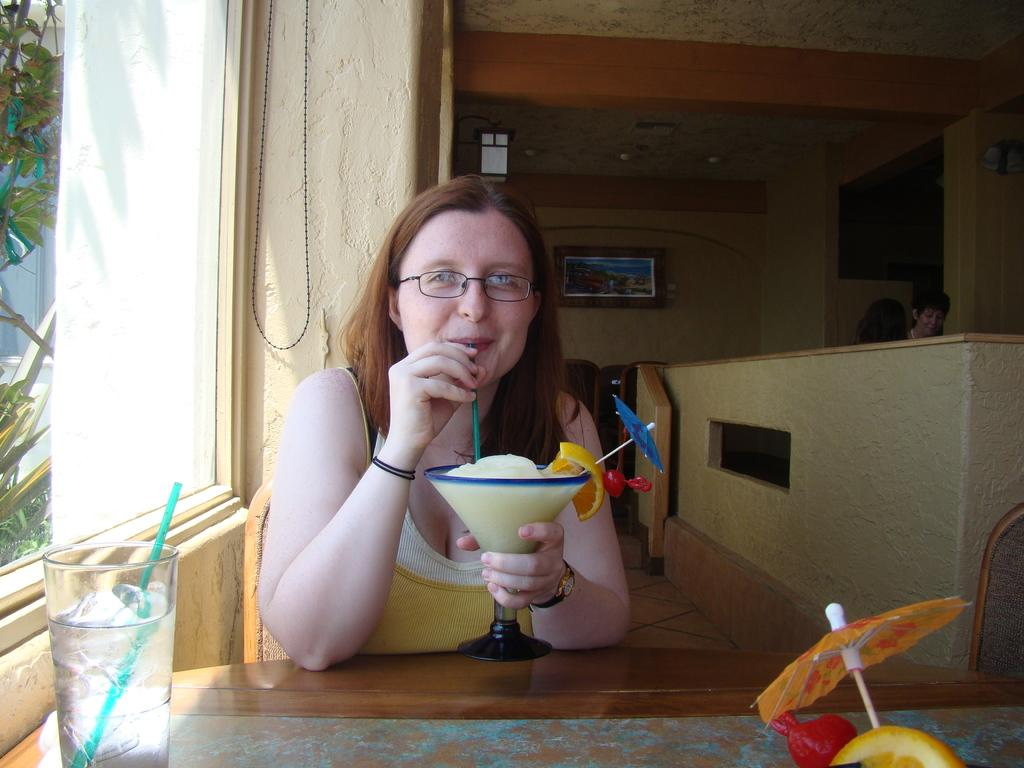Who is present in the image? There is a woman in the image. What is the woman holding in the image? The woman is holding a soft drink. What is the woman's position in the image? The woman is sitting on a chair. What is in front of the woman? There is a table in front of the woman. What is on the table? There is a glass on the table. What is beside the woman? There is a window beside the woman. Where was the image taken? The image was taken in a restaurant. What type of apparel is the cactus wearing in the image? There is no cactus present in the image, and therefore no apparel can be observed. 